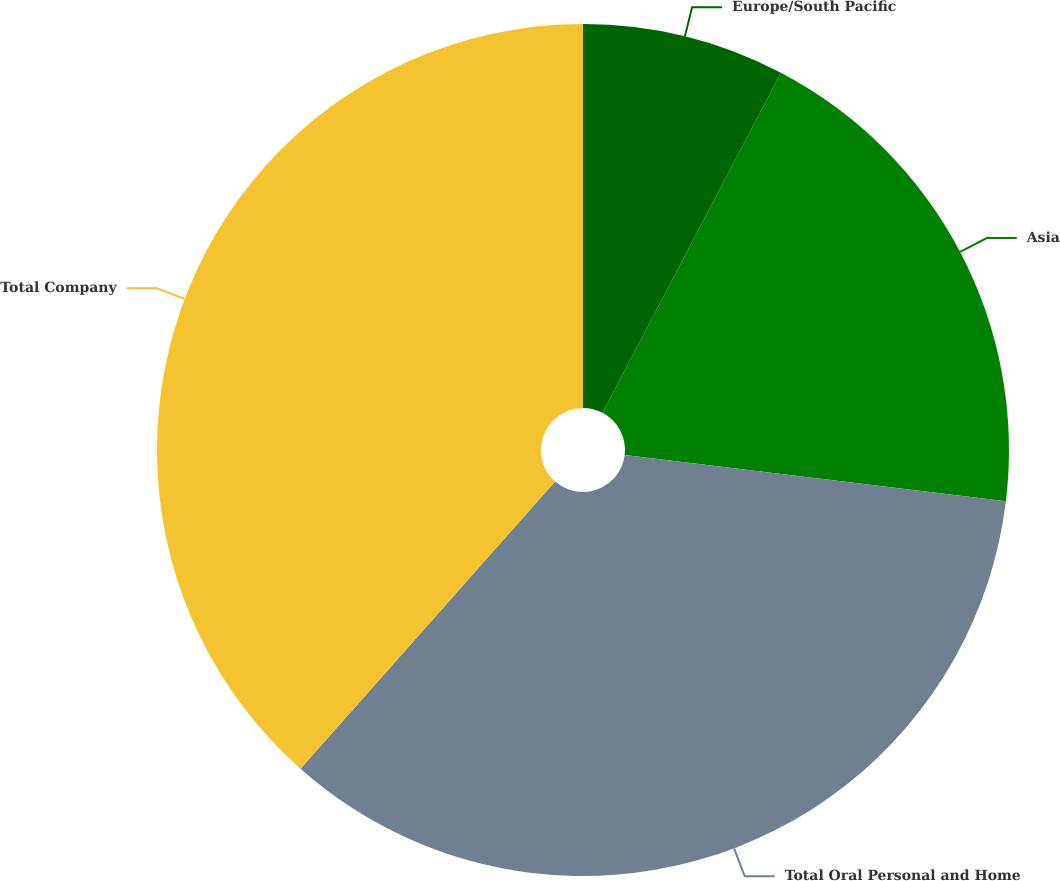<chart> <loc_0><loc_0><loc_500><loc_500><pie_chart><fcel>Europe/South Pacific<fcel>Asia<fcel>Total Oral Personal and Home<fcel>Total Company<nl><fcel>7.69%<fcel>19.23%<fcel>34.62%<fcel>38.46%<nl></chart> 